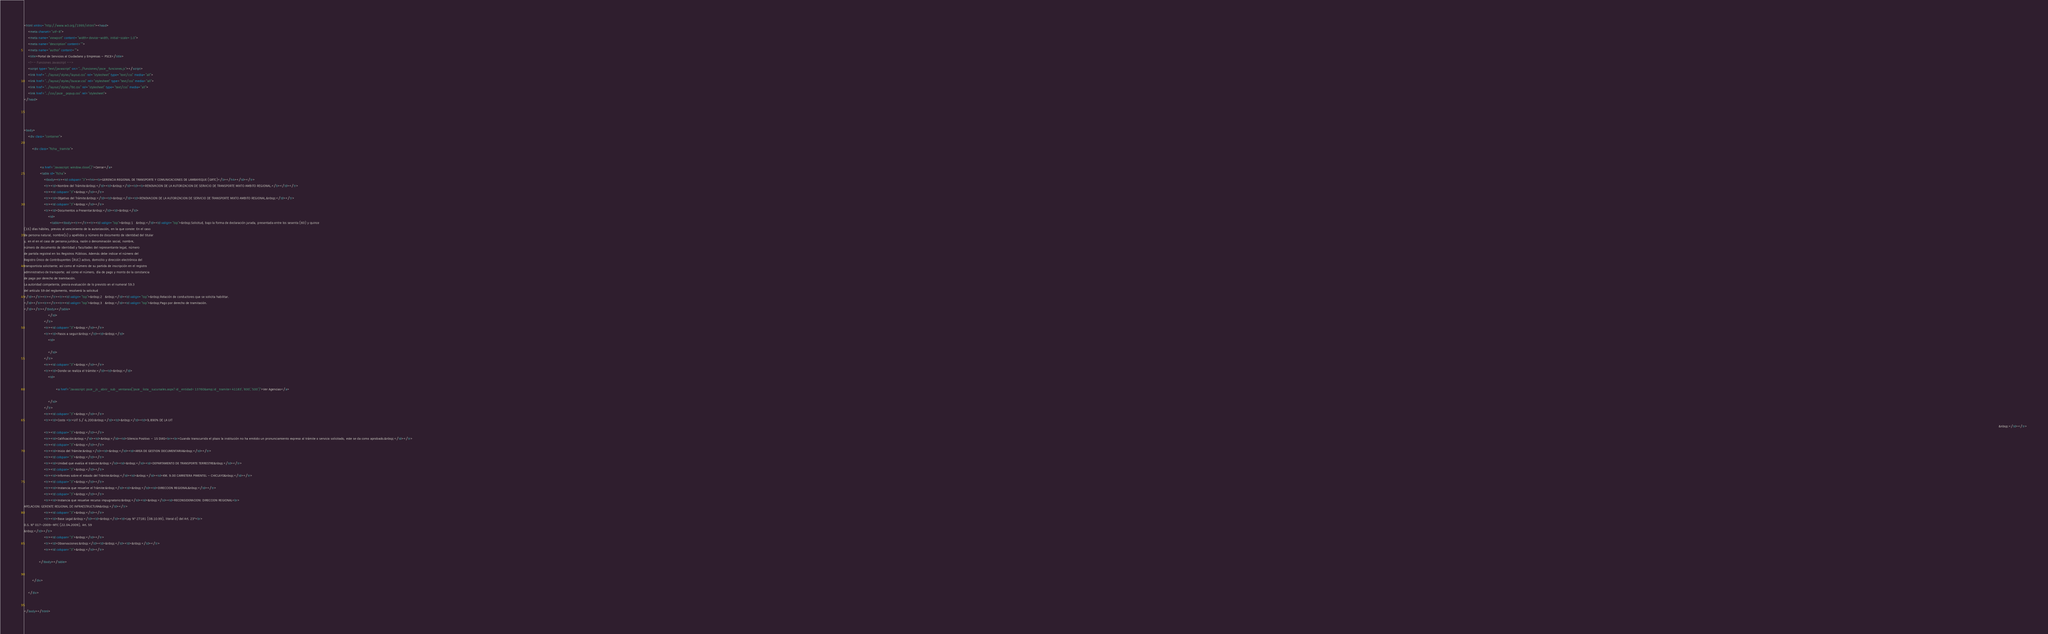Convert code to text. <code><loc_0><loc_0><loc_500><loc_500><_HTML_><html xmlns="http://www.w3.org/1999/xhtml"><head>
    <meta charset="utf-8">
    <meta name="viewport" content="width=device-width, initial-scale=1.0">
    <meta name="description" content="">
    <meta name="author" content="">
    <title>Portal de Servicios al Ciudadano y Empresas - PSCE</title>
    <!-- Funciones Javascript -->
    <script type="text/javascript" src="../funciones/psce_funciones.js"></script>
    <link href="../layout/styles/layout.css" rel="stylesheet" type="text/css" media="all"> 
    <link href="../layout/styles/buscar.css" rel="stylesheet" type="text/css" media="all"> 
    <link href="../layout/styles/fot.css" rel="stylesheet" type="text/css" media="all"> 
    <link href="../css/psce_popup.css" rel="stylesheet">
</head>

 


<body>
    <div class="container">

        <div class="ficha_tramite">

            
                <a href="Javascript: window.close()">Cerrar</a>
                <table id="ficha">
                    <tbody><tr><td colspan="3"><h4><b>GERENCIA REGIONAL DE TRANSPORTE Y COMUNICACIONES DE LAMBAYEQUE (GRTC)</b></h4></td></tr>
                    <tr><td>Nombre del Trámite:&nbsp;</td><td>&nbsp;</td><td><b>RENOVACION DE LA AUTORIZACION DE SERVICIO DE TRANSPORTE MIXTO AMBITO REGIONAL.</b></td></tr>
                    <tr><td colspan="3">&nbsp;</td></tr>
                    <tr><td>Objetivo del Trámite:&nbsp;</td><td>&nbsp;</td><td>RENOVACION DE LA AUTORIZACION DE SERVICIO DE TRANSPORTE MIXTO AMBITO REGIONAL.&nbsp;</td></tr>
                    <tr><td colspan="3">&nbsp;</td></tr>
                    <tr><td>Documentos a Presentar:&nbsp;</td><td>&nbsp;</td>
                        <td>
                          <table><tbody><tr></tr><tr><td valign="top">&nbsp;1   &nbsp;</td><td valign="top">&nbsp;Solicitud, bajo la forma de declaración jurada, presentada entre los sesenta (60) y quince
(15) días hábiles, previos al vencimiento de la autorización, en la que conste: En el caso
de persona natural, nombre(s) y apellidos y número de documento de identidad del titular
y, en el en el caso de persona jurídica, razón o denominación social, nombre,
número de documento de identidad y facultades del representante legal, número
de partida registral en los Registros Públicos. Además debe indicar el número del
Registro Único de Contribuyentes (RUC) activo, domicilio y dirección electrónica del
transportista solicitante; así como el número de su partida de inscripción en el registro
administrativo de transporte; así como el número, día de pago y monto de la constancia
de pago por derecho de tramitación.
La autoridad competente, previa evaluación de lo previsto en el numeral 59.3
del artículo 59 del reglamento, resolverá la solicitud
</td></tr><tr></tr><tr><td valign="top">&nbsp;2   &nbsp;</td><td valign="top">&nbsp;Relación de conductores que se solicita habilitar.
</td></tr><tr></tr><tr><td valign="top">&nbsp;3   &nbsp;</td><td valign="top">&nbsp;Pago por derecho de tramitación.
</td></tr></tbody></table>
                        </td>
                    </tr>
                    <tr><td colspan="3">&nbsp;</td></tr>
                    <tr><td>Pasos a seguir:&nbsp;</td><td>&nbsp;</td>
                        <td>
                            
                        </td>
                    </tr>
                    <tr><td colspan="3">&nbsp;</td></tr>
                    <tr><td>Donde se realiza el trámite:</td><td>&nbsp;</td>
                        <td>
                            
                                <a href="Javascript: psce_js_abrir_sub_ventanas('psce_lista_sucursales.aspx?id_entidad=13760&amp;id_tramite=41183','600','500')">Ver Agencias</a>
                            
                        </td>
                    </tr>   
                    <tr><td colspan="3">&nbsp;</td></tr>
                    <tr><td>Costo <br>UIT S./ 4,200:&nbsp;</td><td>&nbsp;</td><td>9,890% DE LA UIT
                                                                                                                                                                                                                                                                                                                                                                                                                                                                                                                                                                                                                                                                                                                                                                                                                                                                                                                                                                                                                                                                                                                                                                                                                                                                                                                                                                                                                                                                                                                                                                                                                                                                                                                                                                                                                                                                                                                                                                                                                                                              &nbsp;</td></tr>
                    <tr><td colspan="3">&nbsp;</td></tr>
                    <tr><td>Calificación:&nbsp;</td><td>&nbsp;</td><td>Silencio Positivo - 15 DIAS<br><br>Cuando transcurrido el plazo la institución no ha emitido un pronunciamiento expreso al trámite o servicio solicitado, este se da como aprobado.&nbsp;</td></tr>
                    <tr><td colspan="3">&nbsp;</td></tr>
                    <tr><td>Inicio del Trámite:&nbsp;</td><td>&nbsp;</td><td>AREA DE GESTION DOCUMENTARIA&nbsp;</td></tr>
                    <tr><td colspan="3">&nbsp;</td></tr>
                    <tr><td>Unidad que evalúa el trámite:&nbsp;</td><td>&nbsp;</td><td>DEPARTAMENTO DE TRANSPORTE TERRESTRE&nbsp;</td></tr>
                    <tr><td colspan="3">&nbsp;</td></tr>
                    <tr><td>Informes sobre el estado del Trámite:&nbsp;</td><td>&nbsp;</td><td>KM. 9.00 CARRETERA PIMENTEL - CHICLAYO&nbsp;</td></tr>
                    <tr><td colspan="3">&nbsp;</td></tr>
                    <tr><td>Instancia que resuelve el Trámite:&nbsp;</td><td>&nbsp;</td><td>DIRECCION REGIONAL&nbsp;</td></tr>
                    <tr><td colspan="3">&nbsp;</td></tr>
                    <tr><td>Instancia que resuelve recurso impugnatorio:&nbsp;</td><td>&nbsp;</td><td>RECONSIDERACION: DIRECCION REGIONAL<br>
APELACION: GERENTE REGIONAL DE INFRAESTRUCTURA&nbsp;</td></tr>
                    <tr><td colspan="3">&nbsp;</td></tr>
                    <tr><td>Base Legal:&nbsp;</td><td>&nbsp;</td><td>Ley N° 27181 (08.10.99), literal d) del Art. 23°<br>
D.S. Nº 017-2009-MTC (22.04.2009), Art. 59
&nbsp;</td></tr>
                    <tr><td colspan="3">&nbsp;</td></tr>
                    <tr><td>Observaciones:&nbsp;</td><td>&nbsp;</td><td>&nbsp;</td></tr>
                    <tr><td colspan="3">&nbsp;</td></tr>

               </tbody></table>
            
            
        </div>

    </div>


</body></html></code> 